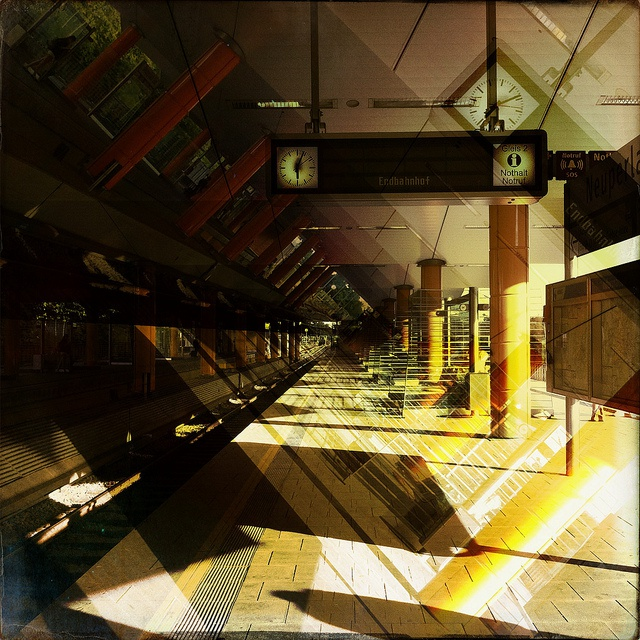Describe the objects in this image and their specific colors. I can see clock in gray, black, and olive tones and clock in gray, tan, olive, and khaki tones in this image. 